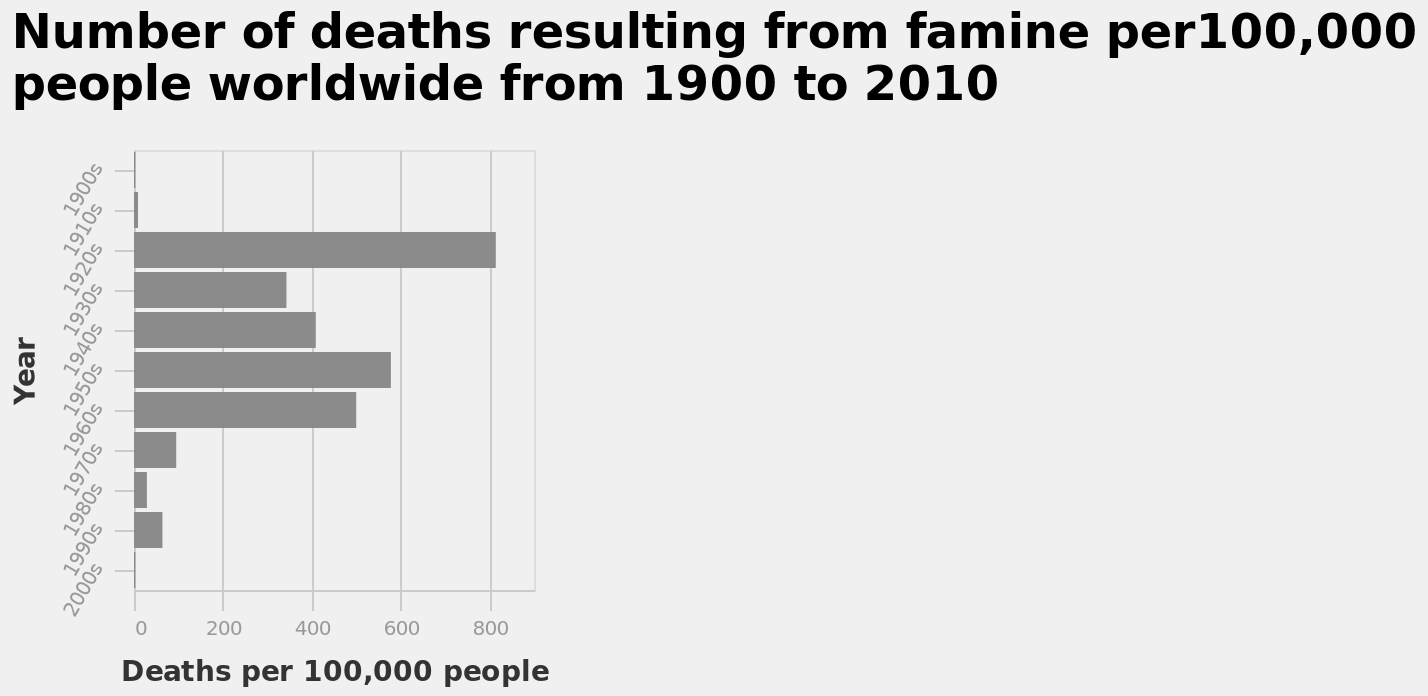<image>
What change occurred in the number of deaths from famine in the 1930s?  There was a definite decrease in the number of deaths from famine in the 1930s. What is the geographic scope of the data used for the bar diagram? The bar diagram represents the number of deaths resulting from famine worldwide. 